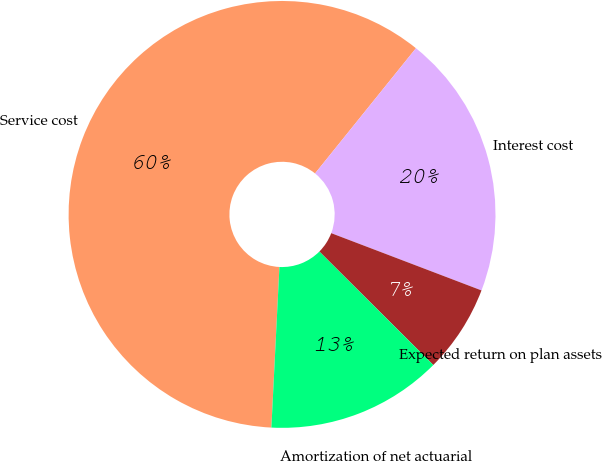Convert chart to OTSL. <chart><loc_0><loc_0><loc_500><loc_500><pie_chart><fcel>Service cost<fcel>Interest cost<fcel>Expected return on plan assets<fcel>Amortization of net actuarial<nl><fcel>60.0%<fcel>20.0%<fcel>6.67%<fcel>13.33%<nl></chart> 